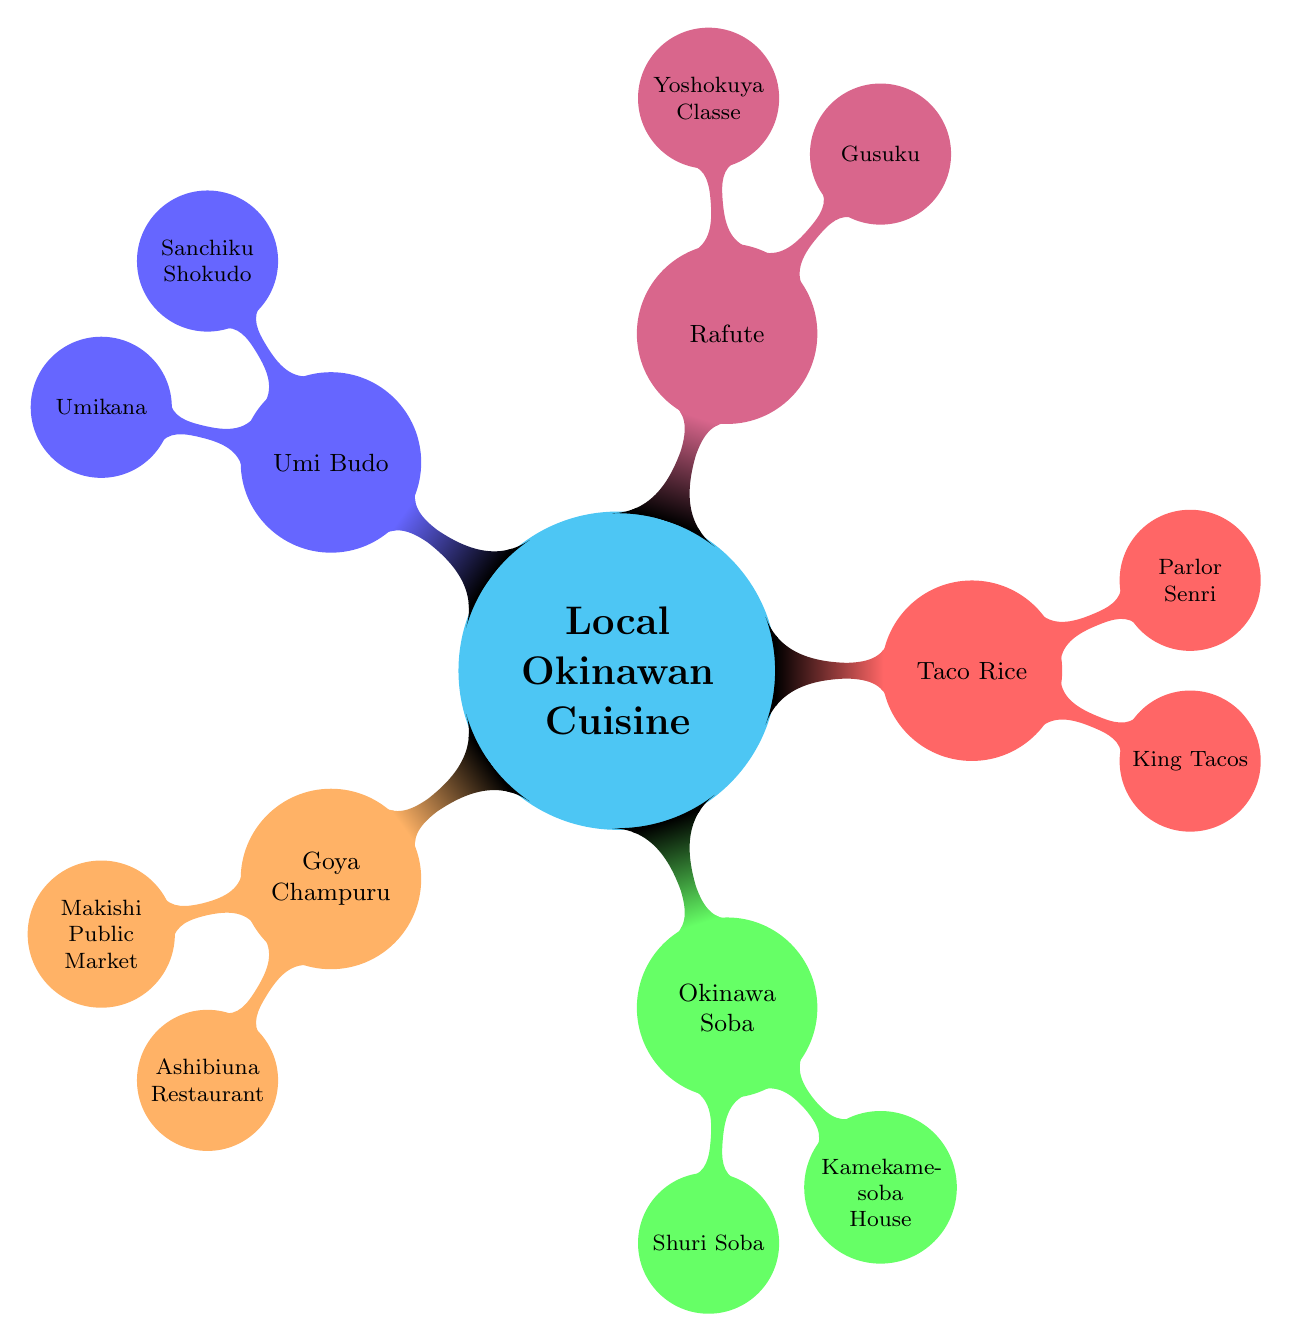What is the main topic of the mind map? The central node of the mind map is labeled as "Local Okinawan Cuisine," which indicates it is the primary subject of the diagram.
Answer: Local Okinawan Cuisine How many dishes are featured in the diagram? Counting the nodes that represent dishes, there are five distinct dishes listed in the diagram: Goya Champuru, Okinawa Soba, Taco Rice, Rafute, and Umi Budo.
Answer: 5 Which dish is associated with "Gusuku"? The node "Gusuku" is listed as one of the top locations under the dish "Rafute," indicating that it is the place to find that particular dish.
Answer: Rafute What type of food is "Umi Budo"? Umi Budo is described as "sea grapes, a type of seaweed," indicating its classification as a seafood or sea vegetable.
Answer: Seaweed Which dishes have "market" or "restaurant" options for locations? Analyzing the nodes, both "Goya Champuru" and "Umi Budo" have eating locations represented by a "market" or "restaurant" – specifically, "Makishi Public Market" and "Ashibiuna Traditional Okinawan Restaurant" for Goya Champuru, and "Sanchiku Shokudo" and "Umikana" for Umi Budo.
Answer: Goya Champuru, Umi Budo Which dish has both noodles and pork? The dish "Okinawa Soba" is specified in the description as having "thick wheat noodles" and "pork," so it fits the criteria.
Answer: Okinawa Soba Name one location where you can find "Taco Rice." The diagram provides two locations for Taco Rice, either "King Tacos" or "Parlor Senri," of which one can be chosen.
Answer: King Tacos What is the primary cooking method used for "Rafute"? According to the description in the diagram, "Rafute" is prepared using the cooking method specified as "braised" pork, which defines how this dish is traditionally cooked.
Answer: Braised 